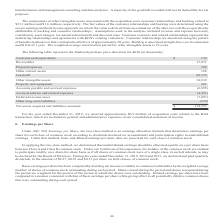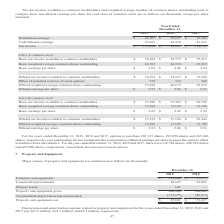According to Mantech International's financial document, How have basic earnings per share been computed during each period? by dividing net income available to common stockholders by the weighted average number of shares of common stock outstanding. The document states: "Basic earnings per share has been computed by dividing net income available to common stockholders by the weighted average number of shares of common ..." Also, How many options to purchase shares were outstanding for the years ended December 31, 2019, and 2018, respectively? The document shows two values: 288,133 and 293,898. From the document: "mber 31, 2019, 2018 and 2017, options to purchase 288,133 shares, 293,898 shares and 265,866 shares, respectively, were outstanding but not included i..." Also, What does the two-class method mean under ASC 360? an earnings allocation formula that determines earnings per share for each class of common stock according to dividends declared (or accumulated) and participation rights in undistributed earnings. The document states: "260, Earnings per Share , the two-class method is an earnings allocation formula that determines earnings per share for each class of common stock acc..." Also, can you calculate: What is the ratio of net income for the year ended December 31, 2018, to 2019? Based on the calculation: $82,097/$113,890 , the result is 0.72. This is based on the information: "ibuted earnings 70,683 42,470 81,432 Net income $ 113,890 $ 82,097 $ 114,141 nings 70,683 42,470 81,432 Net income $ 113,890 $ 82,097 $ 114,141..." The key data points involved are: 113,890, 82,097. Also, can you calculate: What is the percentage change in diluted earnings per share for Class A common stock from the year ended December 31, 2018, to 2019? To answer this question, I need to perform calculations using the financial data. The calculation is: ($2.83-$2.06)/$2.06 , which equals 37.38 (percentage). This is based on the information: "26,678 25,973 Diluted earnings per share $ 2.83 $ 2.06 $ 2.91 27,042 26,678 25,973 Diluted earnings per share $ 2.83 $ 2.06 $ 2.91..." The key data points involved are: 2.06, 2.83. Also, can you calculate: What is the percentage change in diluted earnings per share for Class B common stock from the year ended December 31, 2017, to 2018? To answer this question, I need to perform calculations using the financial data. The calculation is: ($2.06-$2.91)/$2.91 , which equals -29.21 (percentage). This is based on the information: "26,678 25,973 Diluted earnings per share $ 2.83 $ 2.06 $ 2.91 25,973 Diluted earnings per share $ 2.83 $ 2.06 $ 2.91..." The key data points involved are: 2.06, 2.91. 